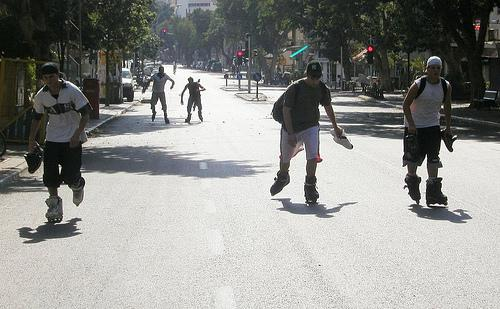Question: why are they skating in the road?
Choices:
A. More room.
B. No traffic.
C. Rebellion.
D. Road closed.
Answer with the letter. Answer: B Question: where are they skating?
Choices:
A. On the sidewalk.
B. At the skate park.
C. In the road.
D. The rink.
Answer with the letter. Answer: C Question: how many boys are behind?
Choices:
A. 3.
B. 4.
C. 1.
D. 2.
Answer with the letter. Answer: D Question: who is skating?
Choices:
A. 3 boys.
B. 5 boys.
C. 2 girls.
D. The older woman.
Answer with the letter. Answer: B Question: who is ahead of the group?
Choices:
A. Man on right.
B. Lady in red.
C. Older man.
D. Guy on the left.
Answer with the letter. Answer: D Question: what color are the lines in the road?
Choices:
A. Yellow.
B. White.
C. Red.
D. Blue.
Answer with the letter. Answer: A 